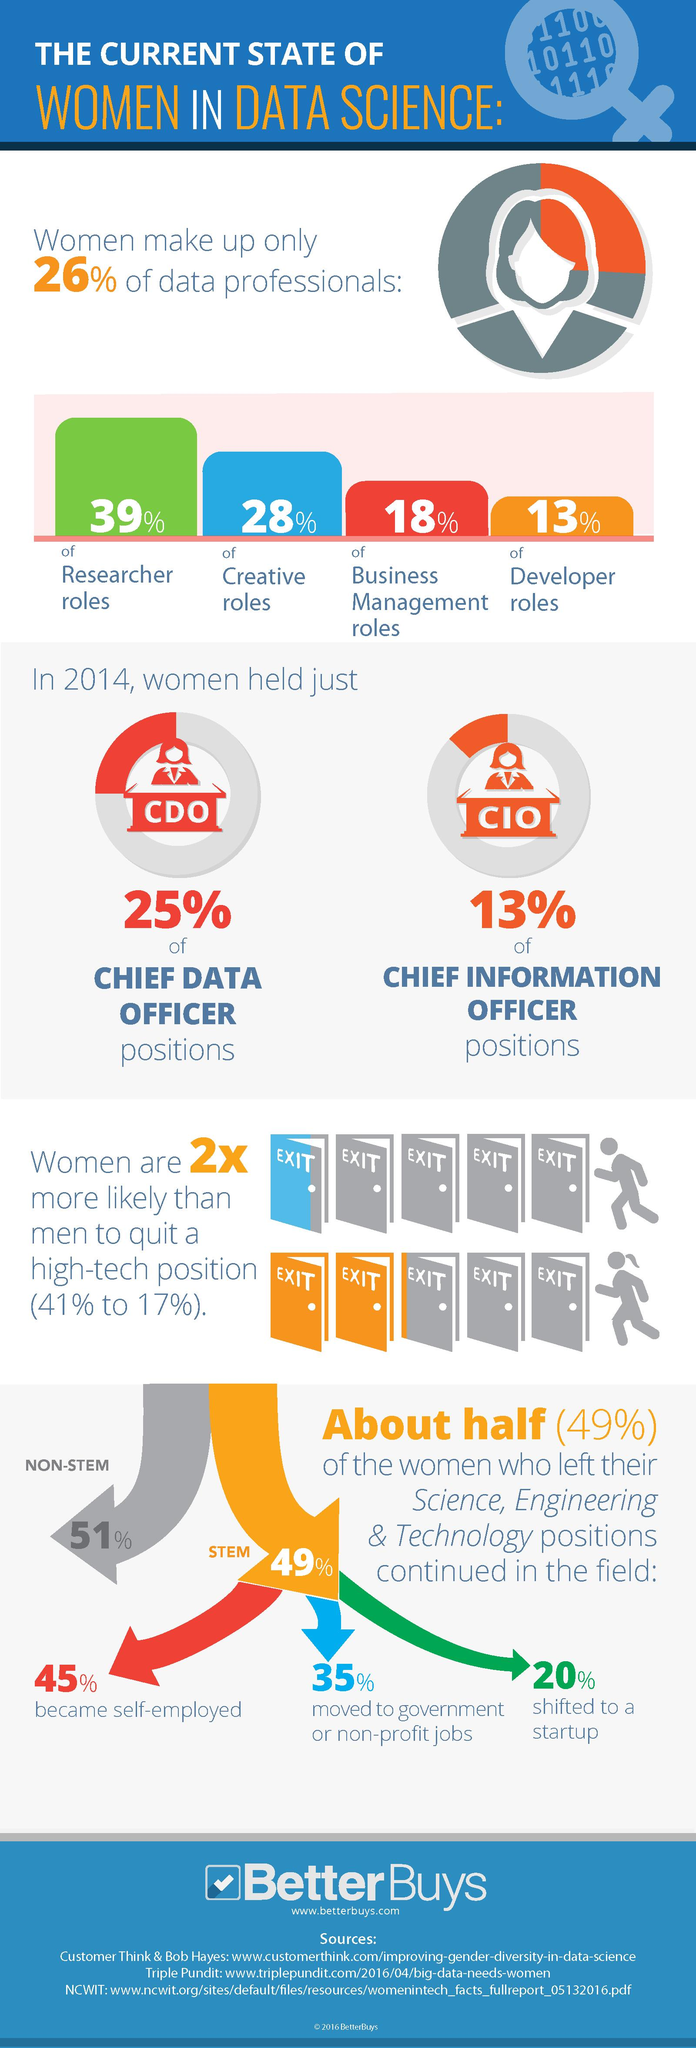Give some essential details in this illustration. Approximately 20% of women who left their science, engineering, and technology positions have shifted to startups. In 2014, approximately 25% of women held chief data positions. According to the information provided, only 13% of developer roles in data science were held by women. According to the data, 45% of women who left their science, engineering, and technology positions became self-employed. According to the data, only 18% of business management roles in data science were occupied by women. 